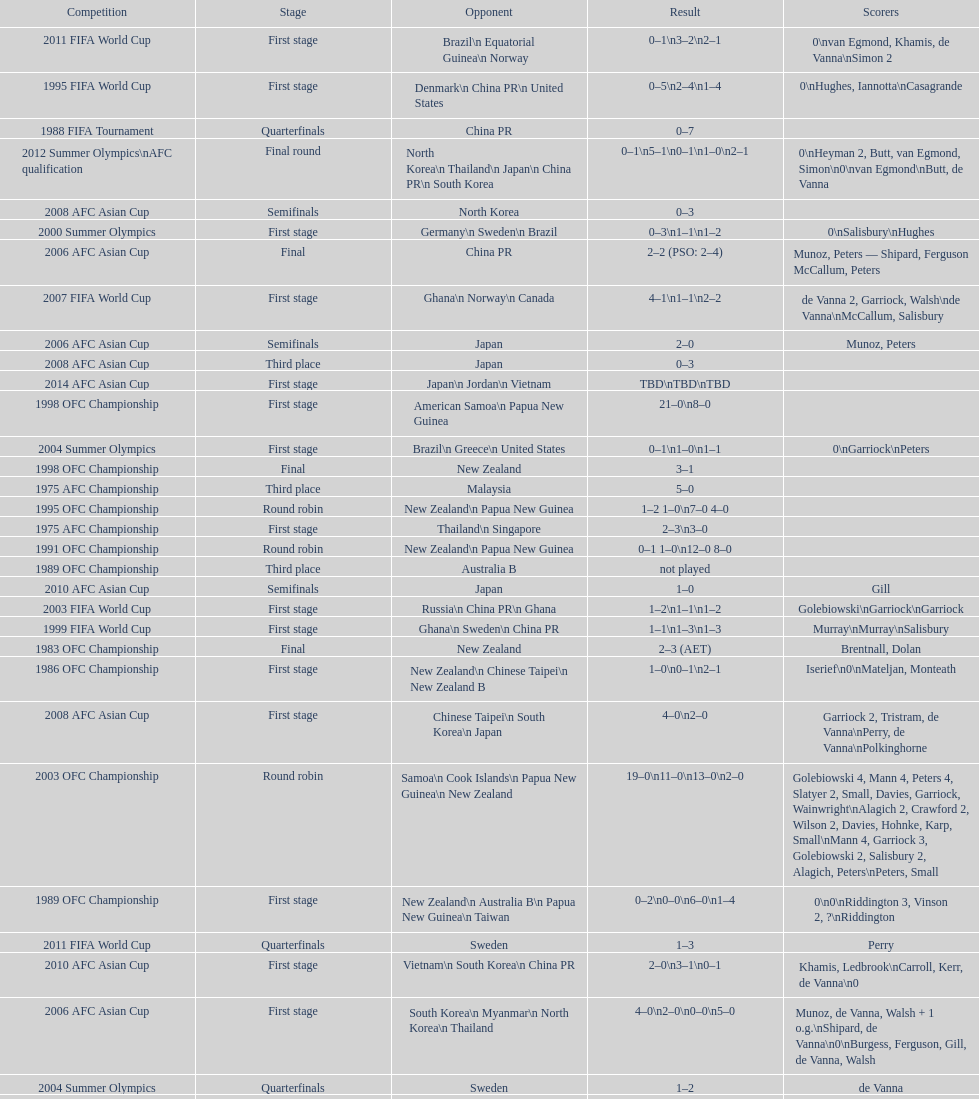Who was the final adversary this team encountered in the 2010 afc asian cup? North Korea. 